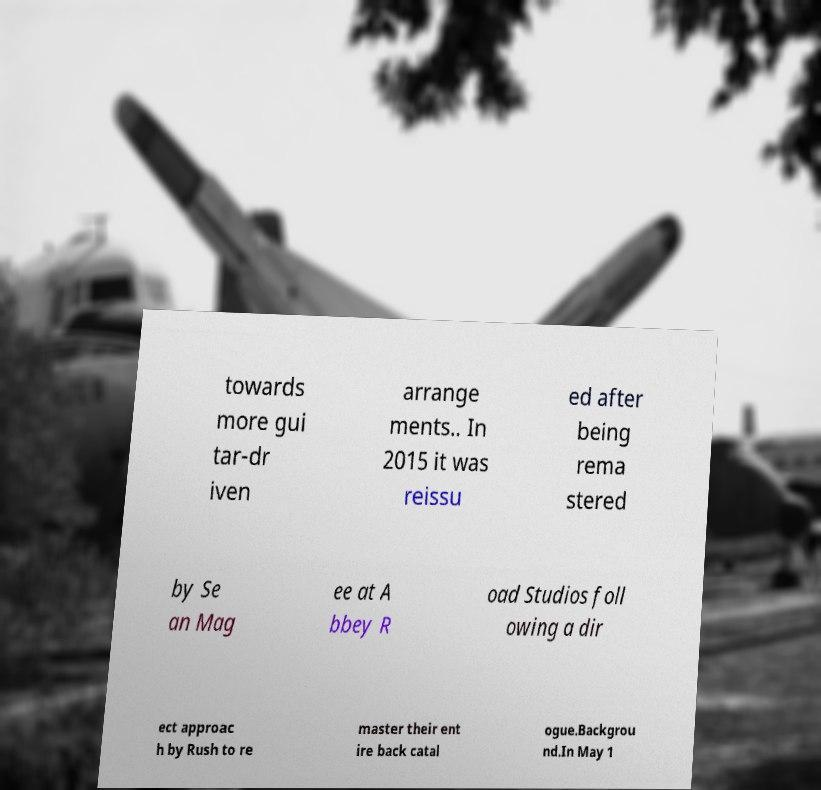There's text embedded in this image that I need extracted. Can you transcribe it verbatim? towards more gui tar-dr iven arrange ments.. In 2015 it was reissu ed after being rema stered by Se an Mag ee at A bbey R oad Studios foll owing a dir ect approac h by Rush to re master their ent ire back catal ogue.Backgrou nd.In May 1 